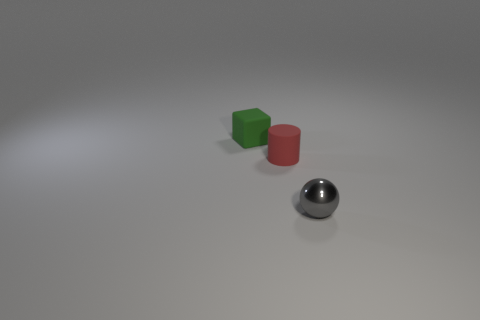What shape is the tiny gray object in front of the tiny rubber thing that is in front of the tiny green rubber object?
Give a very brief answer. Sphere. There is a matte object to the right of the rubber object that is on the left side of the red matte thing; how big is it?
Ensure brevity in your answer.  Small. What color is the rubber thing in front of the rubber cube?
Offer a very short reply. Red. What number of small gray metallic objects have the same shape as the red matte object?
Make the answer very short. 0. There is a ball that is the same size as the green object; what is it made of?
Your response must be concise. Metal. Are there any tiny red things that have the same material as the tiny sphere?
Offer a terse response. No. The tiny thing that is both on the left side of the metal object and in front of the green object is what color?
Give a very brief answer. Red. How many other things are the same color as the tiny shiny ball?
Your answer should be compact. 0. The small thing in front of the small rubber thing in front of the matte thing behind the cylinder is made of what material?
Provide a succinct answer. Metal. What number of cylinders are small green objects or tiny gray metallic things?
Offer a very short reply. 0. 